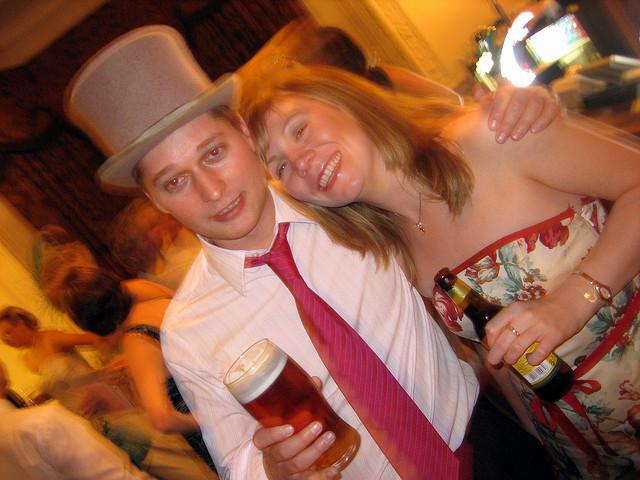What type of hat is the man wearing?
Give a very brief answer. Top hat. Is this couple together?
Concise answer only. Yes. Is the photo blurry?
Write a very short answer. Yes. 